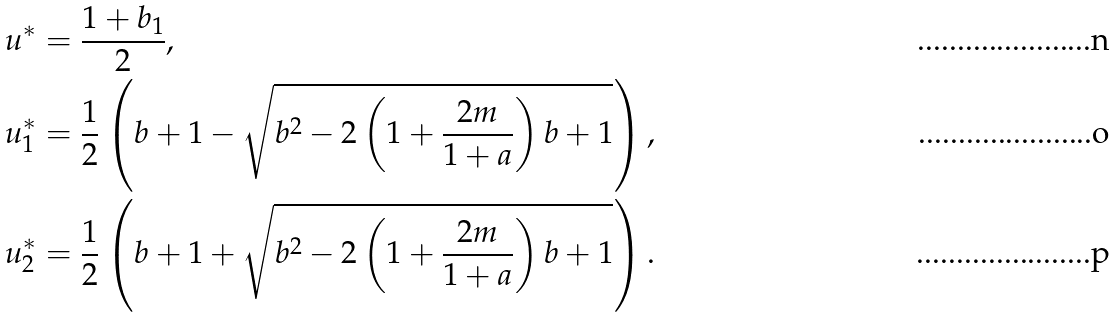Convert formula to latex. <formula><loc_0><loc_0><loc_500><loc_500>& u ^ { * } = \frac { 1 + b _ { 1 } } { 2 } , \\ & u _ { 1 } ^ { * } = \frac { 1 } { 2 } \left ( b + 1 - \sqrt { b ^ { 2 } - 2 \left ( 1 + \frac { 2 m } { 1 + a } \right ) b + 1 } \right ) , \\ & u _ { 2 } ^ { * } = \frac { 1 } { 2 } \left ( b + 1 + \sqrt { b ^ { 2 } - 2 \left ( 1 + \frac { 2 m } { 1 + a } \right ) b + 1 } \right ) .</formula> 